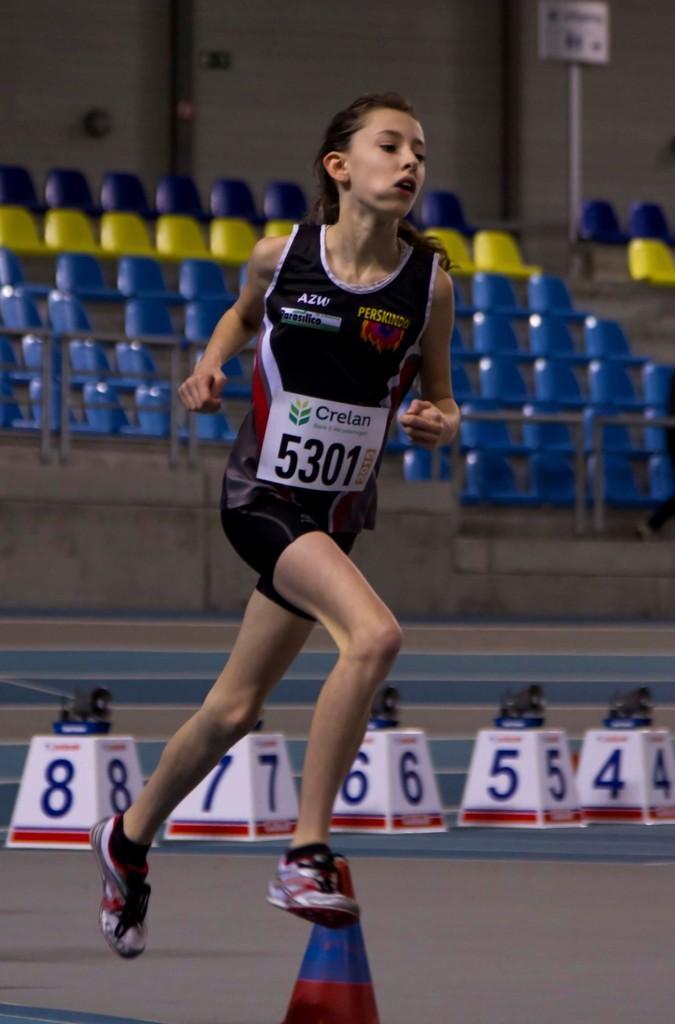In one or two sentences, can you explain what this image depicts? In this image I can see a girl and I can see she is wearing black colour dress. Here I can see white colour paper and on it I can see something is written. In the background I can see number of chairs, few white colour things and on it I can see numbers are written. 